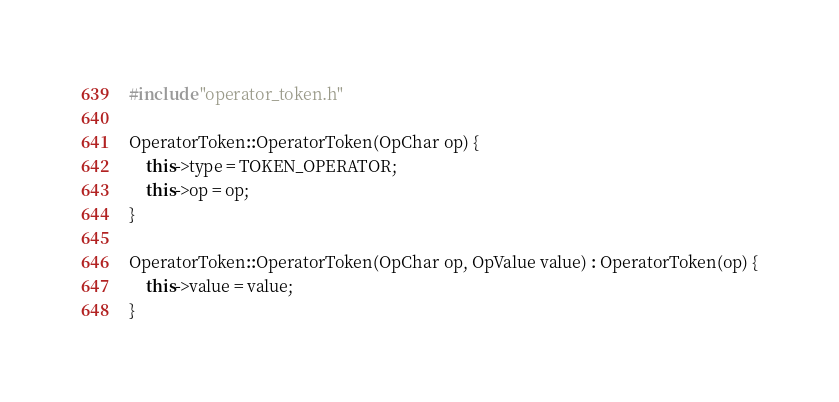Convert code to text. <code><loc_0><loc_0><loc_500><loc_500><_C++_>#include "operator_token.h"

OperatorToken::OperatorToken(OpChar op) {
    this->type = TOKEN_OPERATOR;
    this->op = op;
}

OperatorToken::OperatorToken(OpChar op, OpValue value) : OperatorToken(op) {
    this->value = value;
}
</code> 